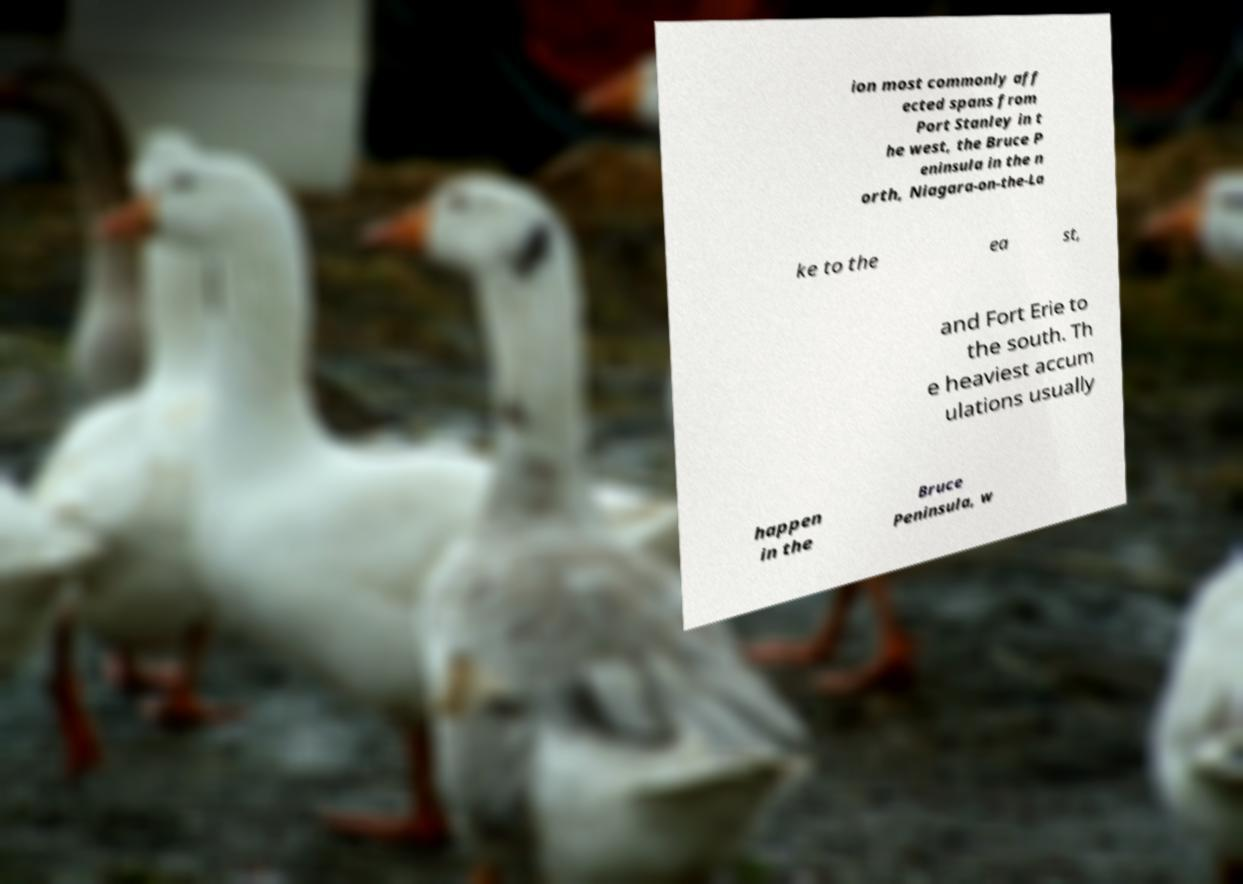Could you extract and type out the text from this image? ion most commonly aff ected spans from Port Stanley in t he west, the Bruce P eninsula in the n orth, Niagara-on-the-La ke to the ea st, and Fort Erie to the south. Th e heaviest accum ulations usually happen in the Bruce Peninsula, w 